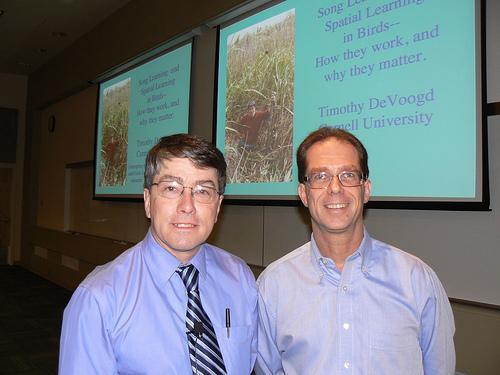How many people are in the photo?
Give a very brief answer. 2. How many eyeglasses are there?
Give a very brief answer. 2. How many people are smiling?
Give a very brief answer. 2. How many images in picture?
Give a very brief answer. 2. How many men are in the room?
Give a very brief answer. 2. How many screens are visible?
Give a very brief answer. 2. How many people are there?
Give a very brief answer. 2. 